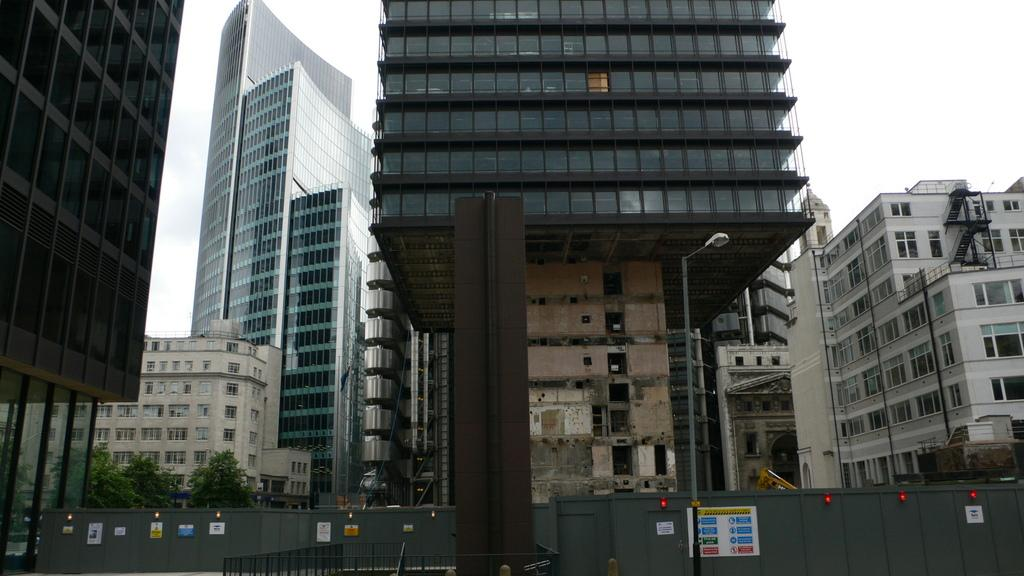What type of structures can be seen in the image? There are buildings in the image. What natural elements are present in the image? There are trees in the image. What is attached to the board in the image? There are posters and lights on the board in the image. What architectural features can be seen in the image? There are railings and poles in the image. What is visible at the top of the image? The sky is visible at the top of the image. Can you see the smile on the book in the image? There is no book present in the image, and therefore no smile can be observed. What type of punishment is being administered to the trees in the image? There is no punishment being administered to the trees in the image; they are simply standing in the background. 